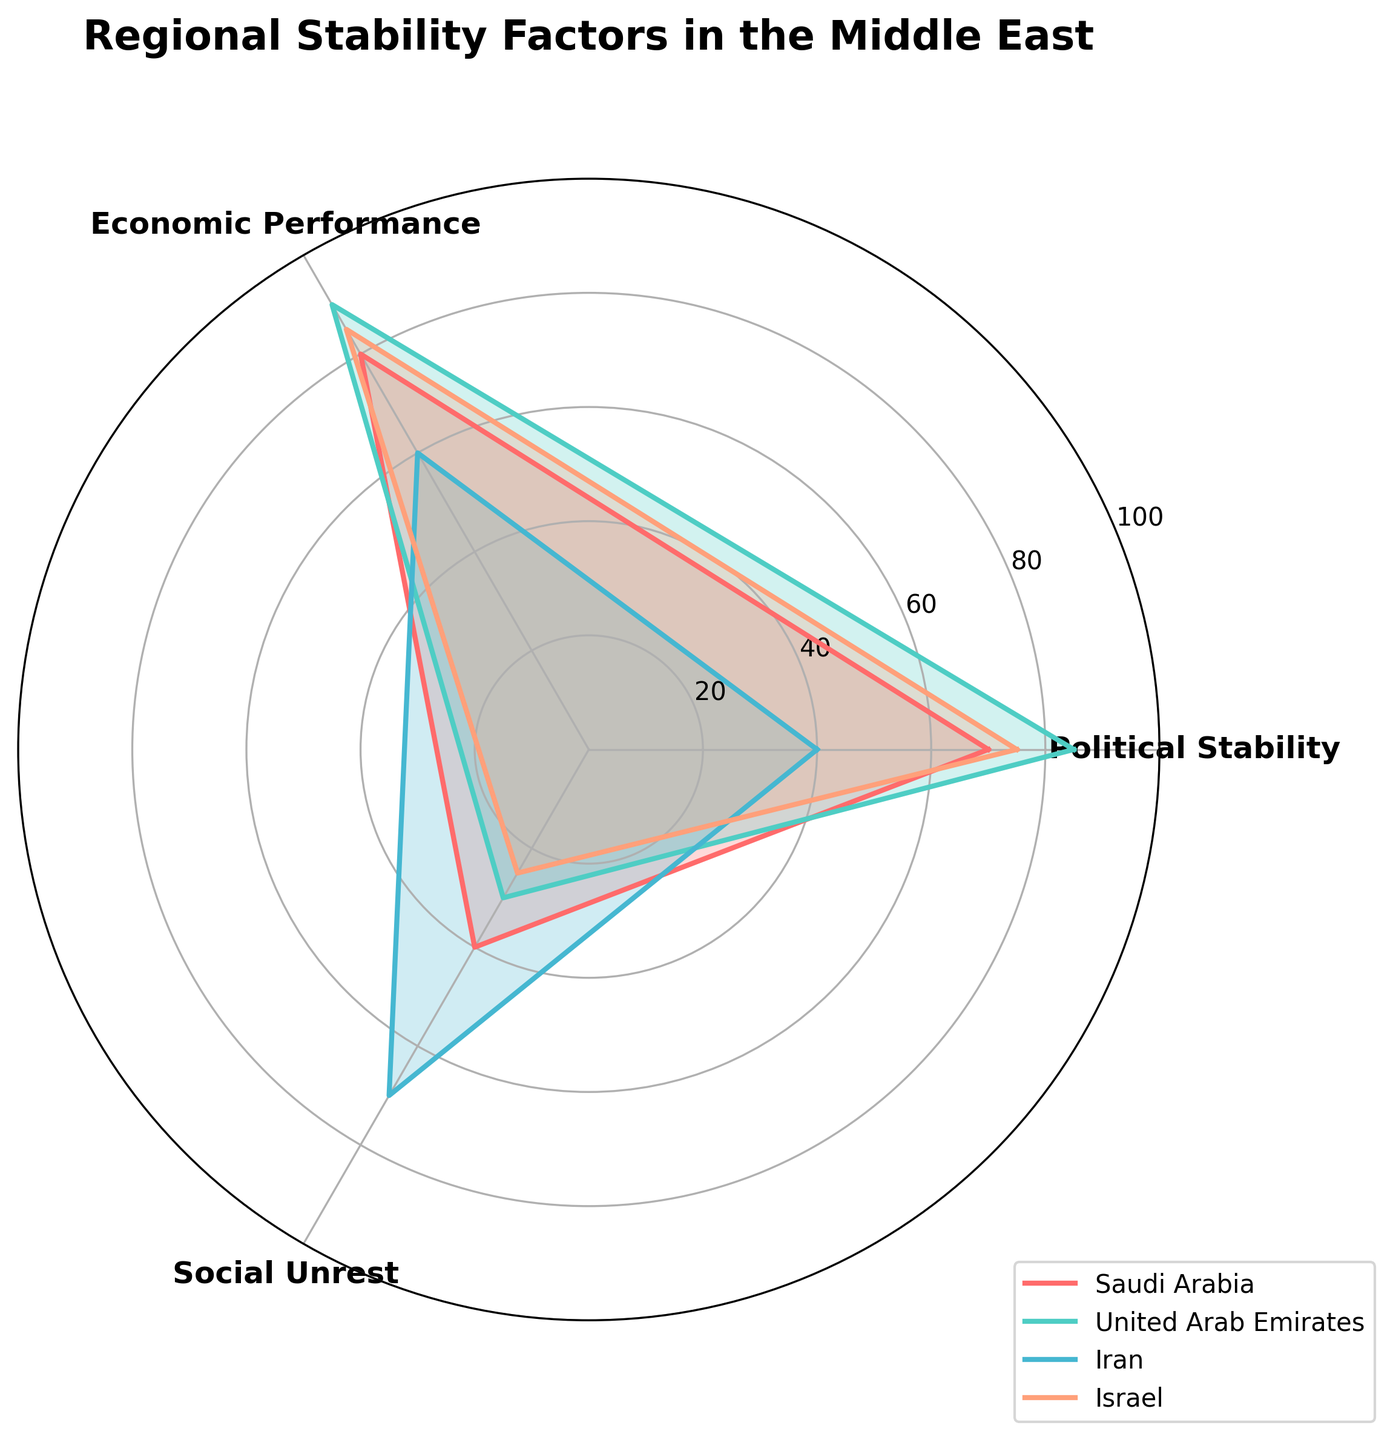What is the title of the radar chart? The title is written at the top of the radar chart. It clearly states the topic visualized in the chart.
Answer: Regional Stability Factors in the Middle East Which country has the highest score in Economic Performance? By looking at the radar chart, the highest point on the Economic Performance axis will indicate which country has the highest score.
Answer: United Arab Emirates For which country is Social Unrest the highest? By examining the Social Unrest axis, the country reaching the furthest along this axis will have the highest Social Unrest score.
Answer: Iran How do Political Stability and Economic Performance compare for Israel? Look at the lengths of Israel's data points on the two axes: Political Stability and Economic Performance. Compare their distances from the center.
Answer: Economic Performance is higher Which country shows the least variability across the three factors? Identify the country with the most equal distances from the center across all axes. UAE and Israel should be closely analyzed, as their values are quite balanced.
Answer: Israel What is the average score for Political Stability across all countries? Sum the Political Stability scores for all countries (70 + 85 + 40 + 75) and divide by the number of countries (4). So, (70 + 85 + 40 + 75) / 4 = 270 / 4 = 67.5
Answer: 67.5 Between Saudi Arabia and Iran, which country has lower Economic Performance? Identify the Economic Performance scores for Saudi Arabia and Iran on the radar chart and compare them. Saudi Arabia has a score of 80 while Iran has 60.
Answer: Iran What is the average Social Unrest score of Saudi Arabia and Israel? Add the Social Unrest scores of Saudi Arabia and Israel (40 + 25) and divide by 2. So, (40 + 25) / 2 = 65 / 2 = 32.5
Answer: 32.5 Which factor is most consistently high across all countries? Examine the relative levels of each factor (Political Stability, Economic Performance, Social Unrest) and determine which factor has the highest minimum value across all countries.
Answer: Economic Performance Of the highlighted countries, which one appears to have the best overall balance between Political Stability, Economic Performance, and Social Unrest? Look for the country whose values are all moderately high and relatively close on all axes. Israel appears balanced with no extreme low.
Answer: Israel 